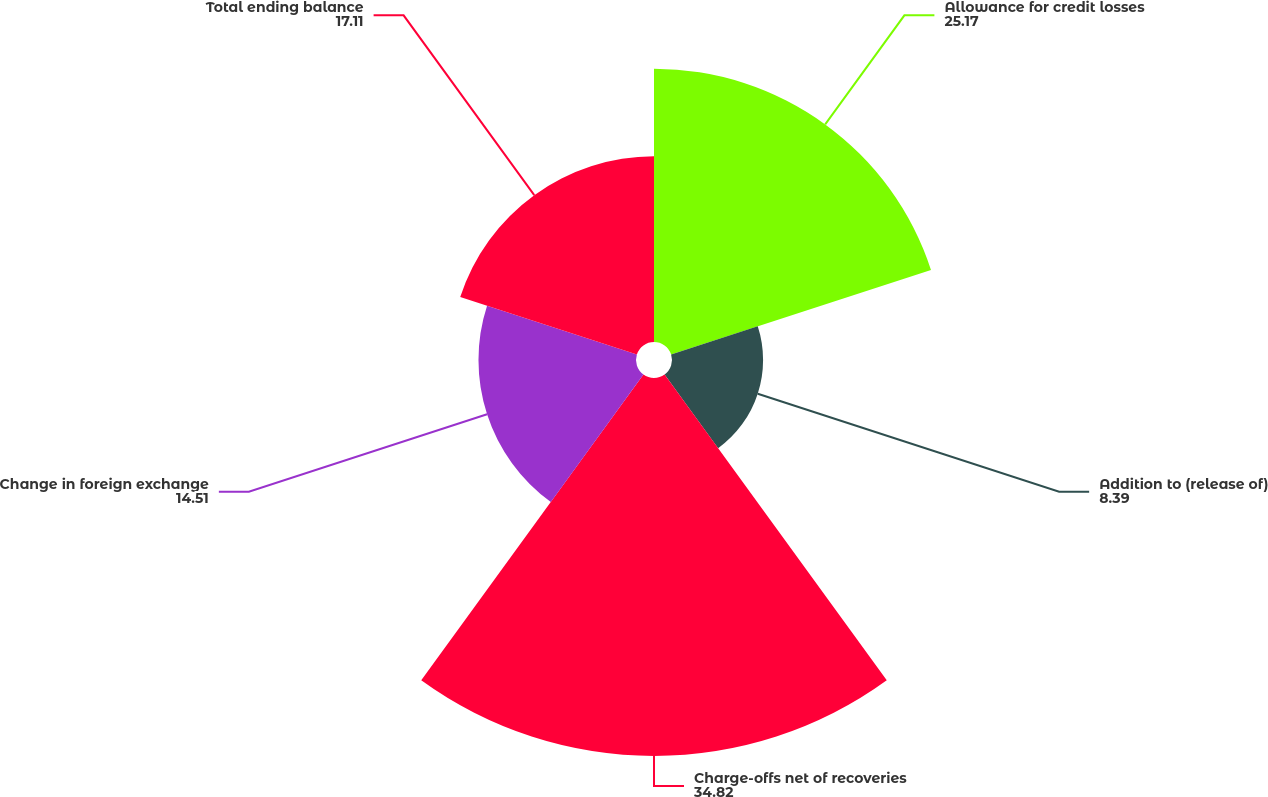Convert chart to OTSL. <chart><loc_0><loc_0><loc_500><loc_500><pie_chart><fcel>Allowance for credit losses<fcel>Addition to (release of)<fcel>Charge-offs net of recoveries<fcel>Change in foreign exchange<fcel>Total ending balance<nl><fcel>25.17%<fcel>8.39%<fcel>34.82%<fcel>14.51%<fcel>17.11%<nl></chart> 